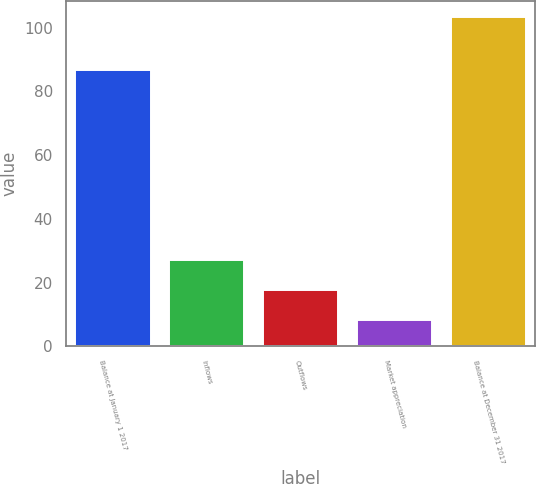Convert chart. <chart><loc_0><loc_0><loc_500><loc_500><bar_chart><fcel>Balance at January 1 2017<fcel>Inflows<fcel>Outflows<fcel>Market appreciation<fcel>Balance at December 31 2017<nl><fcel>86.6<fcel>27.2<fcel>17.7<fcel>8.2<fcel>103.2<nl></chart> 